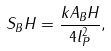<formula> <loc_0><loc_0><loc_500><loc_500>S _ { B } H = \frac { k A _ { B } H } { 4 l _ { P } ^ { 2 } } ,</formula> 